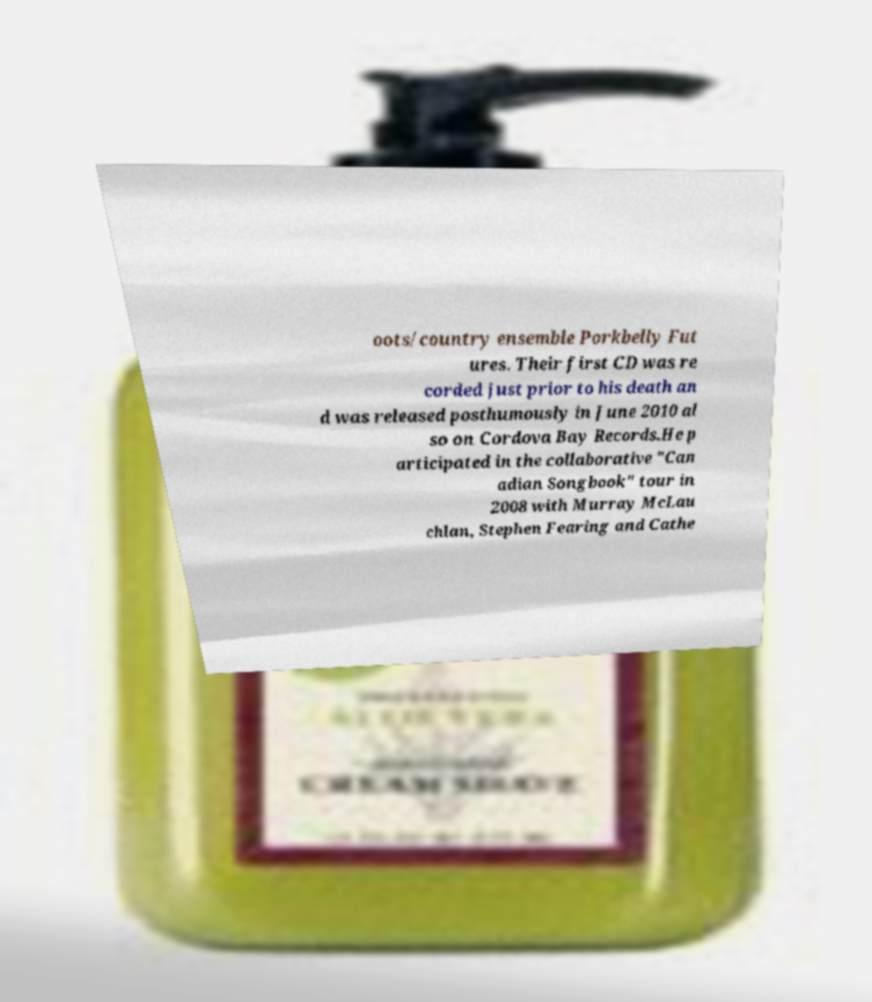Can you read and provide the text displayed in the image?This photo seems to have some interesting text. Can you extract and type it out for me? oots/country ensemble Porkbelly Fut ures. Their first CD was re corded just prior to his death an d was released posthumously in June 2010 al so on Cordova Bay Records.He p articipated in the collaborative "Can adian Songbook" tour in 2008 with Murray McLau chlan, Stephen Fearing and Cathe 